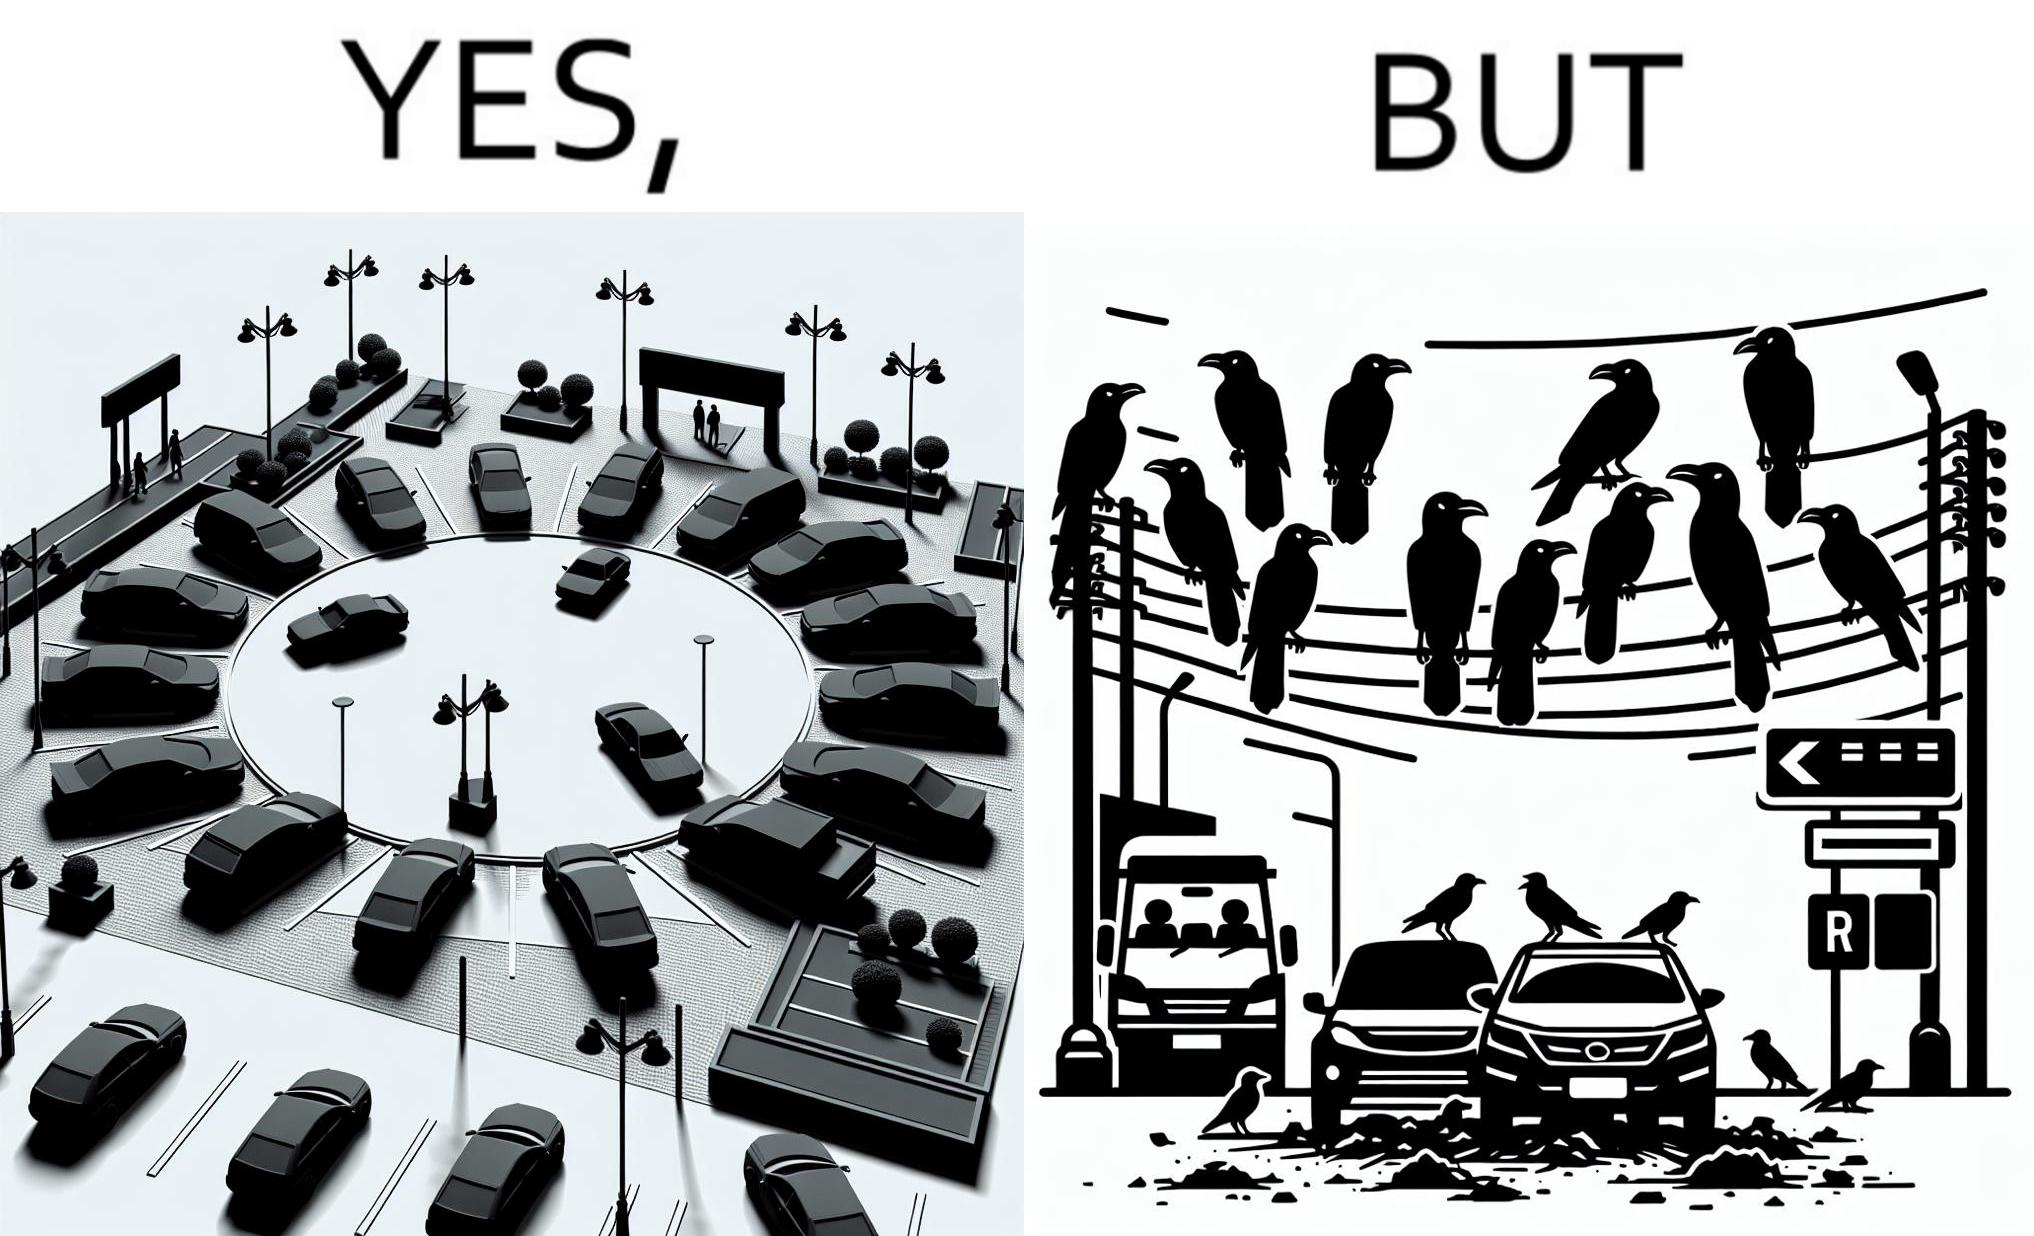Explain why this image is satirical. The image is ironical such that although there is a place for parking but that place is not suitable because if we place our car there then our car will become dirty from top due to crow beet. 